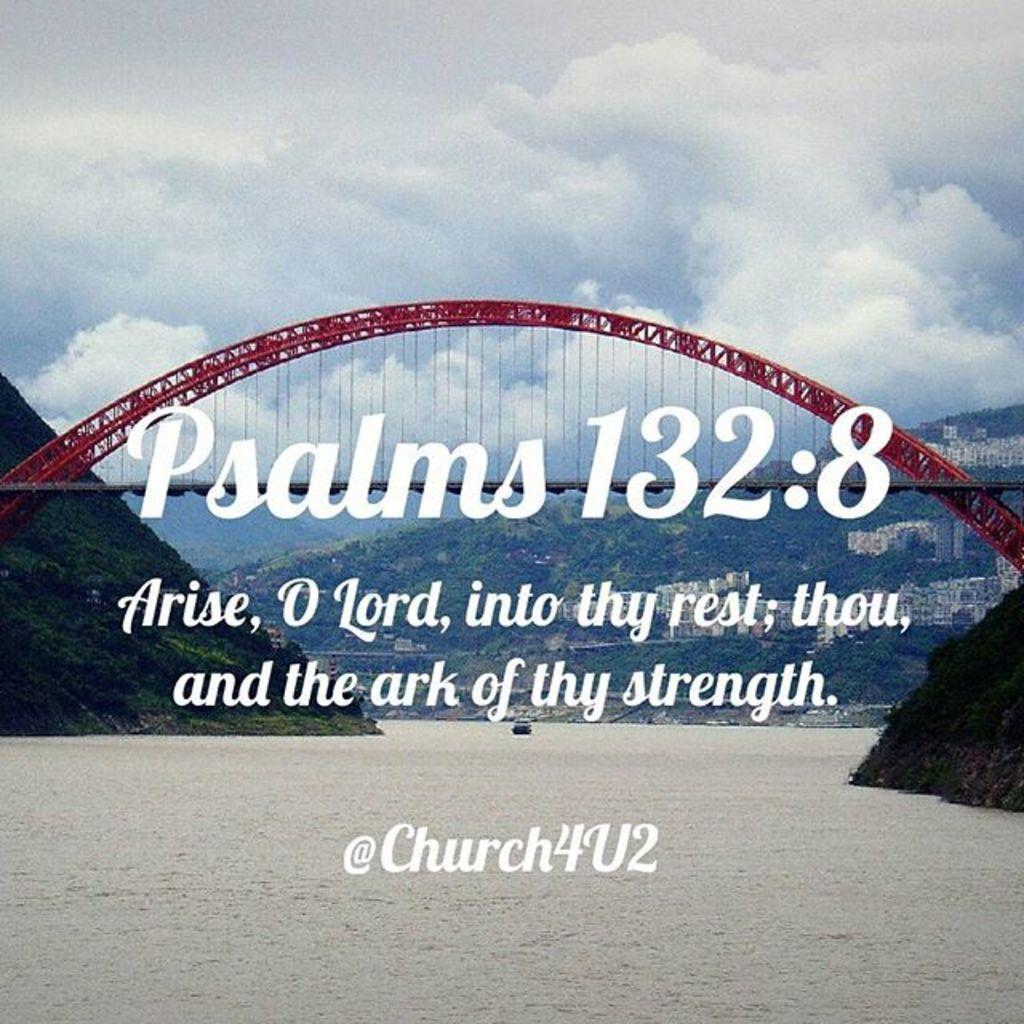What structure is the main subject of the image? There is a bridge in the image. What can be seen in the background of the image? There are trees, hills, and buildings in the background of the image. What is the condition of the sky in the image? The sky is cloudy in the image. What else is present in the image besides the bridge and background elements? There are texts present in the image. What type of comb is being used to measure the leaves in the image? There is no comb or leaves present in the image; it features a bridge, background elements, and texts. 